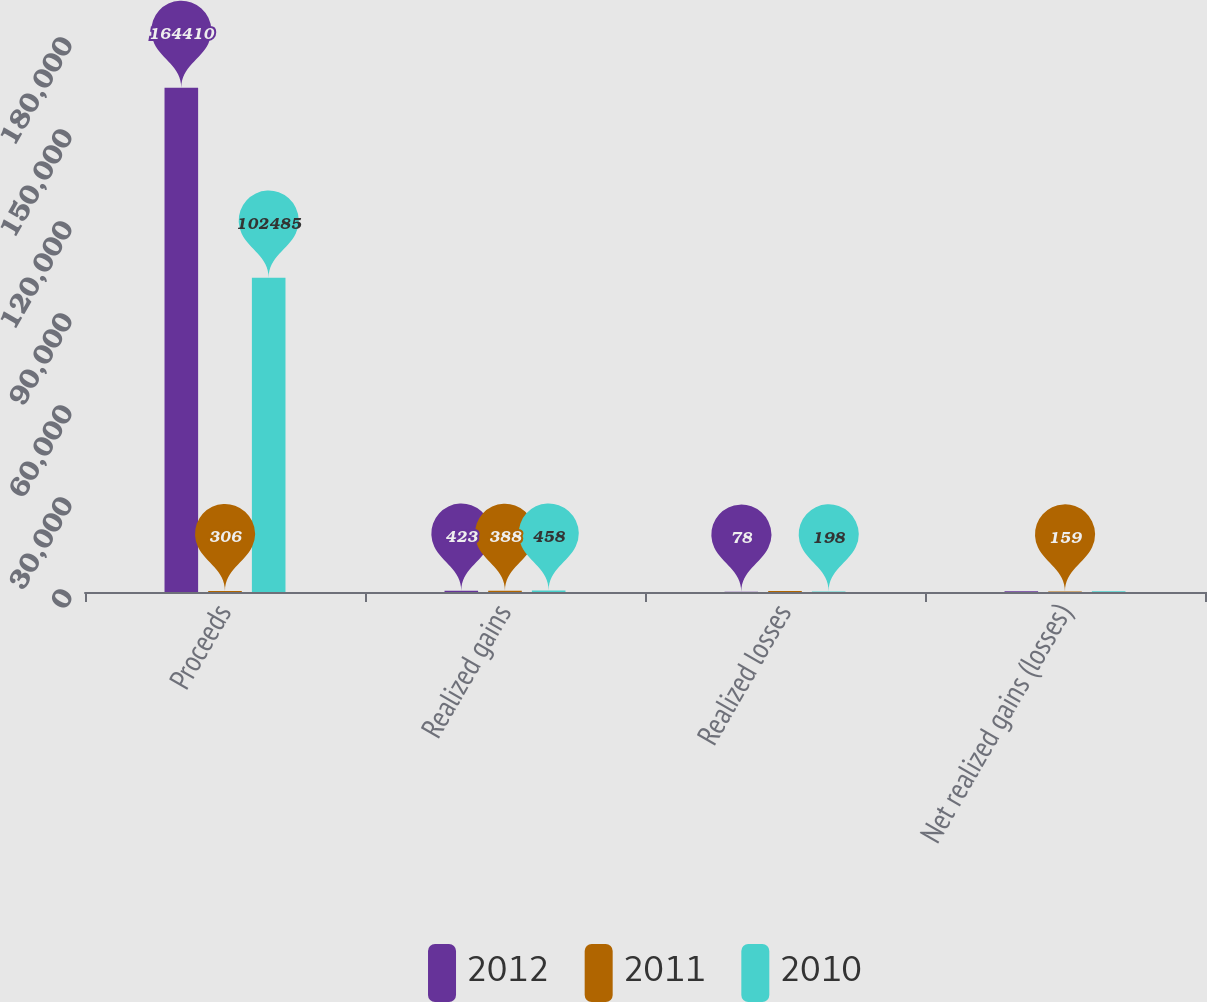Convert chart. <chart><loc_0><loc_0><loc_500><loc_500><stacked_bar_chart><ecel><fcel>Proceeds<fcel>Realized gains<fcel>Realized losses<fcel>Net realized gains (losses)<nl><fcel>2012<fcel>164410<fcel>423<fcel>78<fcel>285<nl><fcel>2011<fcel>306<fcel>388<fcel>306<fcel>159<nl><fcel>2010<fcel>102485<fcel>458<fcel>198<fcel>264<nl></chart> 